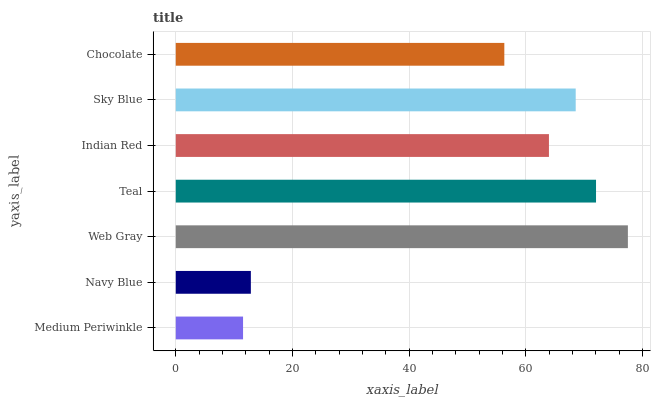Is Medium Periwinkle the minimum?
Answer yes or no. Yes. Is Web Gray the maximum?
Answer yes or no. Yes. Is Navy Blue the minimum?
Answer yes or no. No. Is Navy Blue the maximum?
Answer yes or no. No. Is Navy Blue greater than Medium Periwinkle?
Answer yes or no. Yes. Is Medium Periwinkle less than Navy Blue?
Answer yes or no. Yes. Is Medium Periwinkle greater than Navy Blue?
Answer yes or no. No. Is Navy Blue less than Medium Periwinkle?
Answer yes or no. No. Is Indian Red the high median?
Answer yes or no. Yes. Is Indian Red the low median?
Answer yes or no. Yes. Is Navy Blue the high median?
Answer yes or no. No. Is Sky Blue the low median?
Answer yes or no. No. 